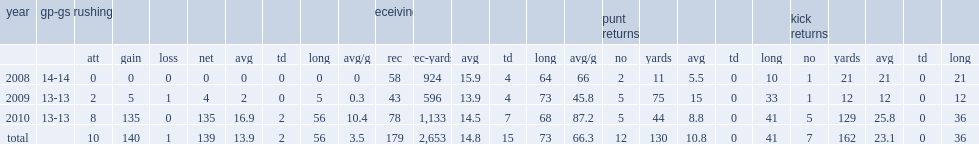How many career receptions did jones have in total? 179.0. Can you parse all the data within this table? {'header': ['year', 'gp-gs', 'rushing', '', '', '', '', '', '', '', 'receiving', '', '', '', '', '', 'punt returns', '', '', '', '', 'kick returns', '', '', '', ''], 'rows': [['', '', 'att', 'gain', 'loss', 'net', 'avg', 'td', 'long', 'avg/g', 'rec', 'rec-yards', 'avg', 'td', 'long', 'avg/g', 'no', 'yards', 'avg', 'td', 'long', 'no', 'yards', 'avg', 'td', 'long'], ['2008', '14-14', '0', '0', '0', '0', '0', '0', '0', '0', '58', '924', '15.9', '4', '64', '66', '2', '11', '5.5', '0', '10', '1', '21', '21', '0', '21'], ['2009', '13-13', '2', '5', '1', '4', '2', '0', '5', '0.3', '43', '596', '13.9', '4', '73', '45.8', '5', '75', '15', '0', '33', '1', '12', '12', '0', '12'], ['2010', '13-13', '8', '135', '0', '135', '16.9', '2', '56', '10.4', '78', '1,133', '14.5', '7', '68', '87.2', '5', '44', '8.8', '0', '41', '5', '129', '25.8', '0', '36'], ['total', '', '10', '140', '1', '139', '13.9', '2', '56', '3.5', '179', '2,653', '14.8', '15', '73', '66.3', '12', '130', '10.8', '0', '41', '7', '162', '23.1', '0', '36']]} 